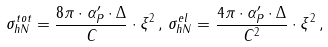Convert formula to latex. <formula><loc_0><loc_0><loc_500><loc_500>\sigma ^ { t o t } _ { h N } = \frac { 8 \pi \cdot \alpha ^ { \prime } _ { P } \cdot \Delta } { C } \cdot \xi ^ { 2 } \, , \, \sigma ^ { e l } _ { h N } = \frac { 4 \pi \cdot \alpha ^ { \prime } _ { P } \cdot \Delta } { C ^ { 2 } } \cdot \xi ^ { 2 } \, ,</formula> 